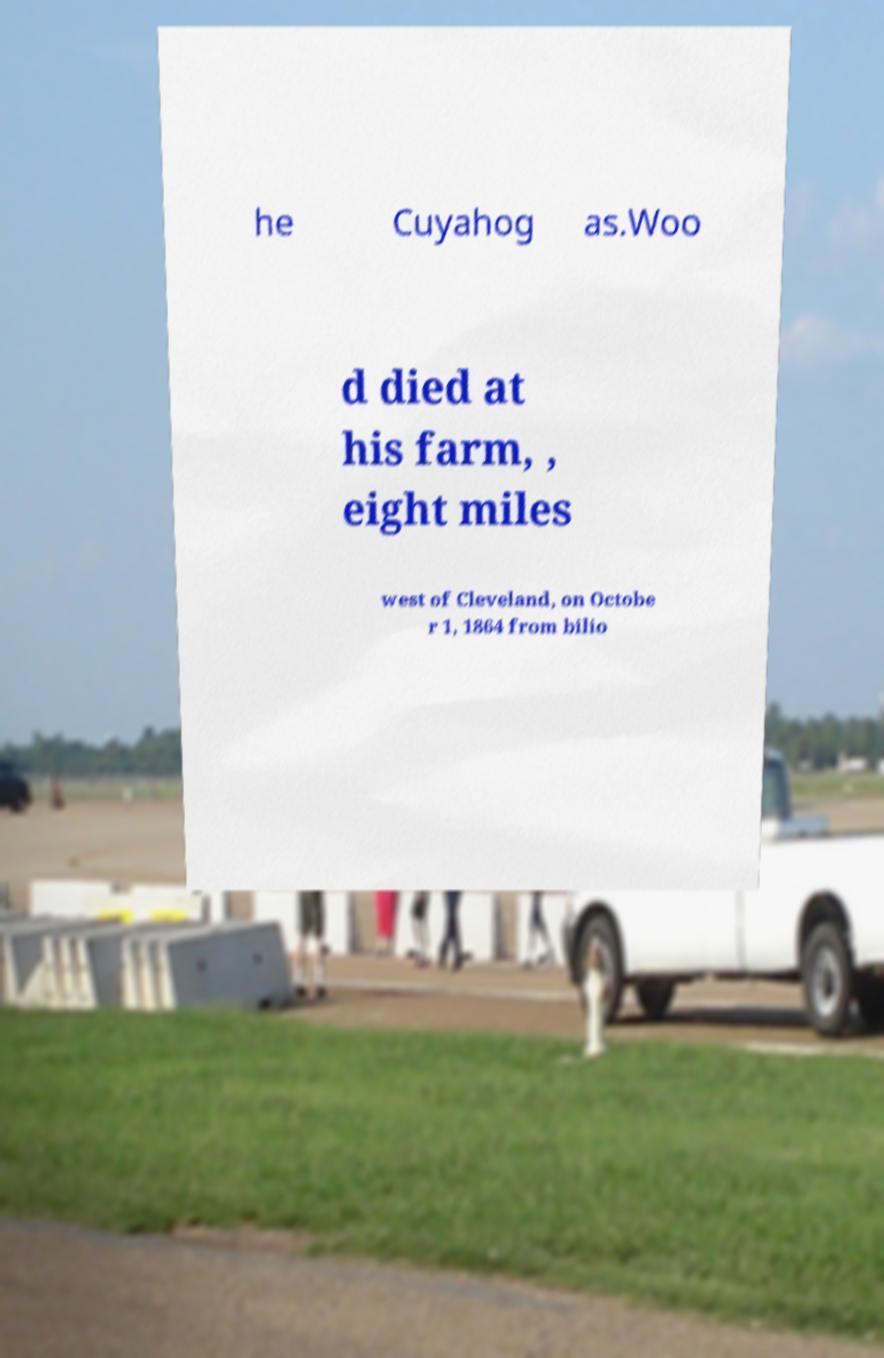Please read and relay the text visible in this image. What does it say? he Cuyahog as.Woo d died at his farm, , eight miles west of Cleveland, on Octobe r 1, 1864 from bilio 